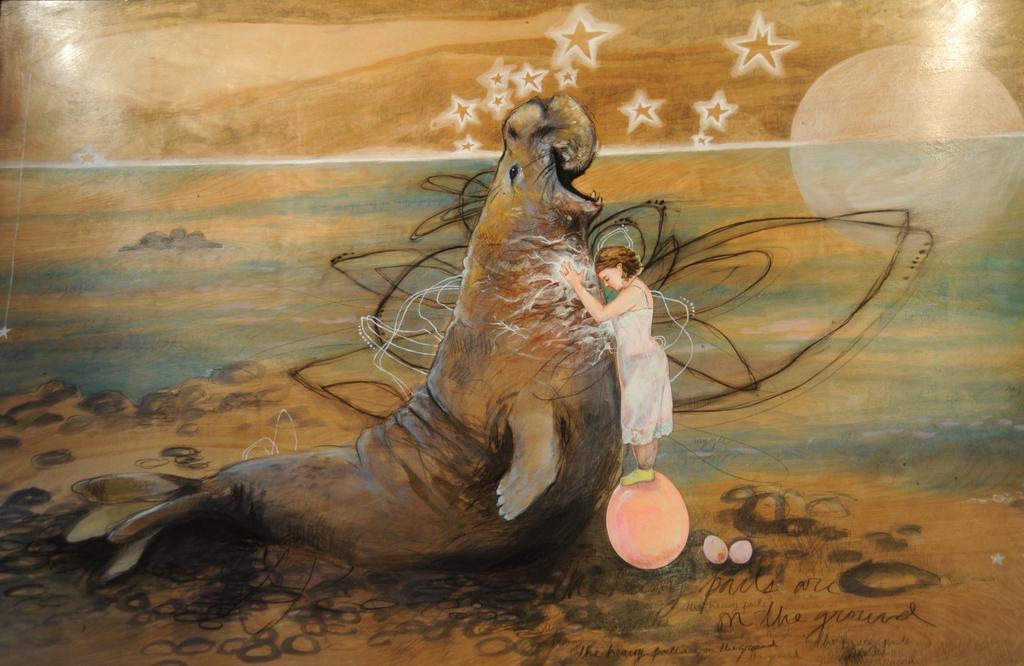Could you give a brief overview of what you see in this image? In this image there is a painting of a person standing on the ball and touching a sea lion in the water , and in the background there are stars,moon. 